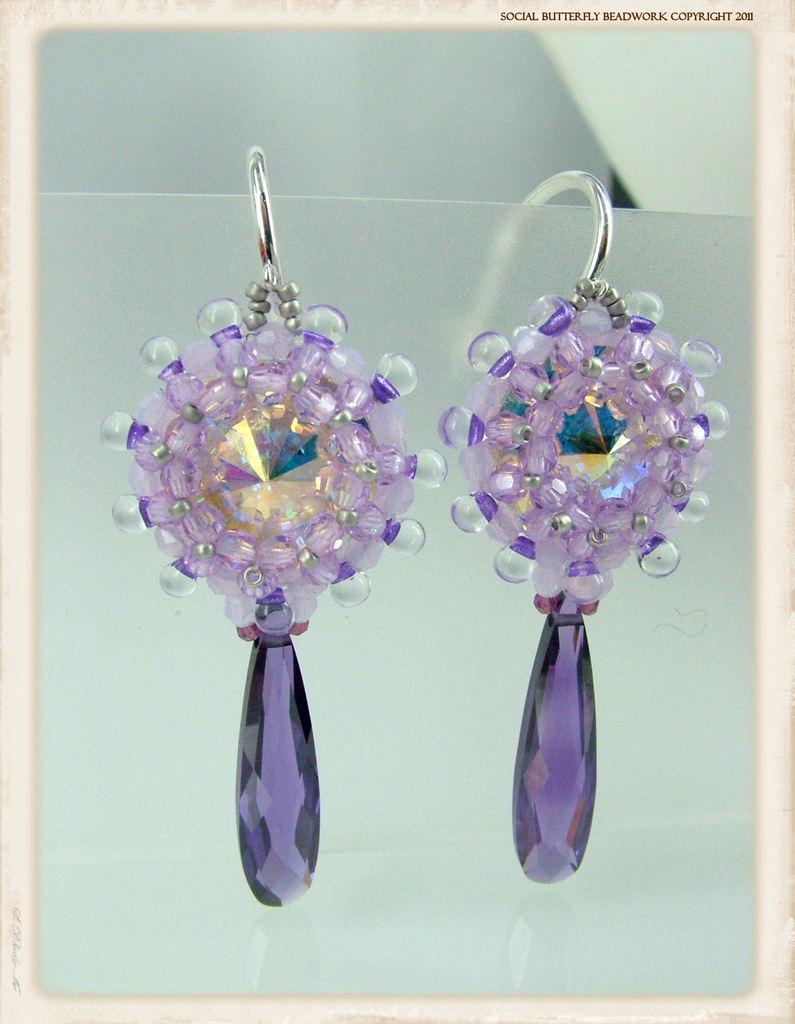In one or two sentences, can you explain what this image depicts? In this image there are two earrings kept on the card. On the right side top there is some text. It looks like a frame in which there are earrings. 